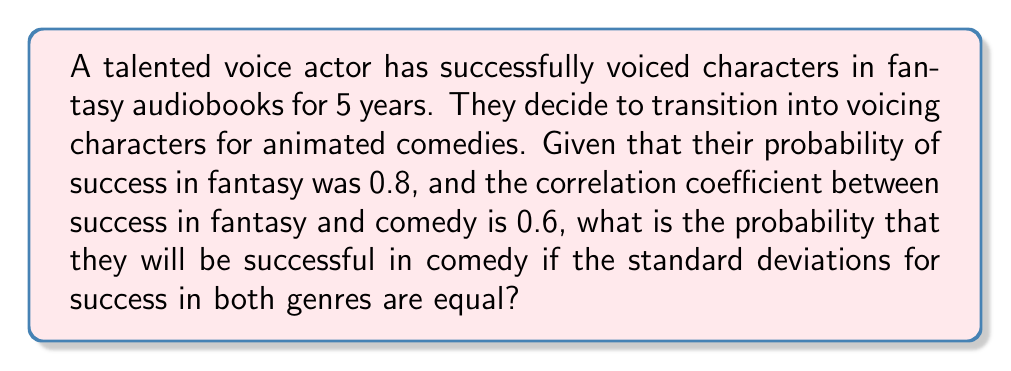Help me with this question. To solve this problem, we'll use the concept of bivariate normal distribution and correlation. Let's break it down step-by-step:

1) Let X represent success in fantasy and Y represent success in comedy.

2) We're given:
   - P(X > 0) = 0.8 (probability of success in fantasy)
   - ρ = 0.6 (correlation coefficient between X and Y)
   - σ_X = σ_Y (standard deviations are equal)

3) For a standard normal distribution, P(Z > z) = 0.8 corresponds to z ≈ -0.84 (using a z-table or calculator).

4) Since P(X > 0) = 0.8, we can say that:
   $$ \frac{0 - μ_X}{σ_X} = -0.84 $$

5) This means μ_X = 0.84σ_X

6) Now, we can use the formula for conditional expectation in a bivariate normal distribution:
   $$ E[Y|X] = μ_Y + ρ\frac{σ_Y}{σ_X}(X - μ_X) $$

7) Since σ_X = σ_Y, this simplifies to:
   $$ E[Y|X] = μ_Y + ρ(X - μ_X) $$

8) We don't know μ_Y, but we know that X = 0 (the threshold for success). Substituting:
   $$ E[Y|X=0] = μ_Y + ρ(0 - 0.84σ_X) = μ_Y - 0.504σ_Y $$

9) The probability of success in comedy is P(Y > 0). This occurs when:
   $$ \frac{0 - (μ_Y - 0.504σ_Y)}{σ_Y} < Z $$

10) Simplifying: $$ \frac{-μ_Y + 0.504σ_Y}{σ_Y} < Z $$

11) We don't know μ_Y/σ_Y, but we can assume it's the same as μ_X/σ_X (0.84) since both are measures of how much easier than average it is to succeed in each field.

12) Substituting: $$ -0.84 + 0.504 < Z $$
    $$ -0.336 < Z $$

13) Using a z-table or calculator, we find that P(Z > -0.336) ≈ 0.6316
Answer: 0.6316 